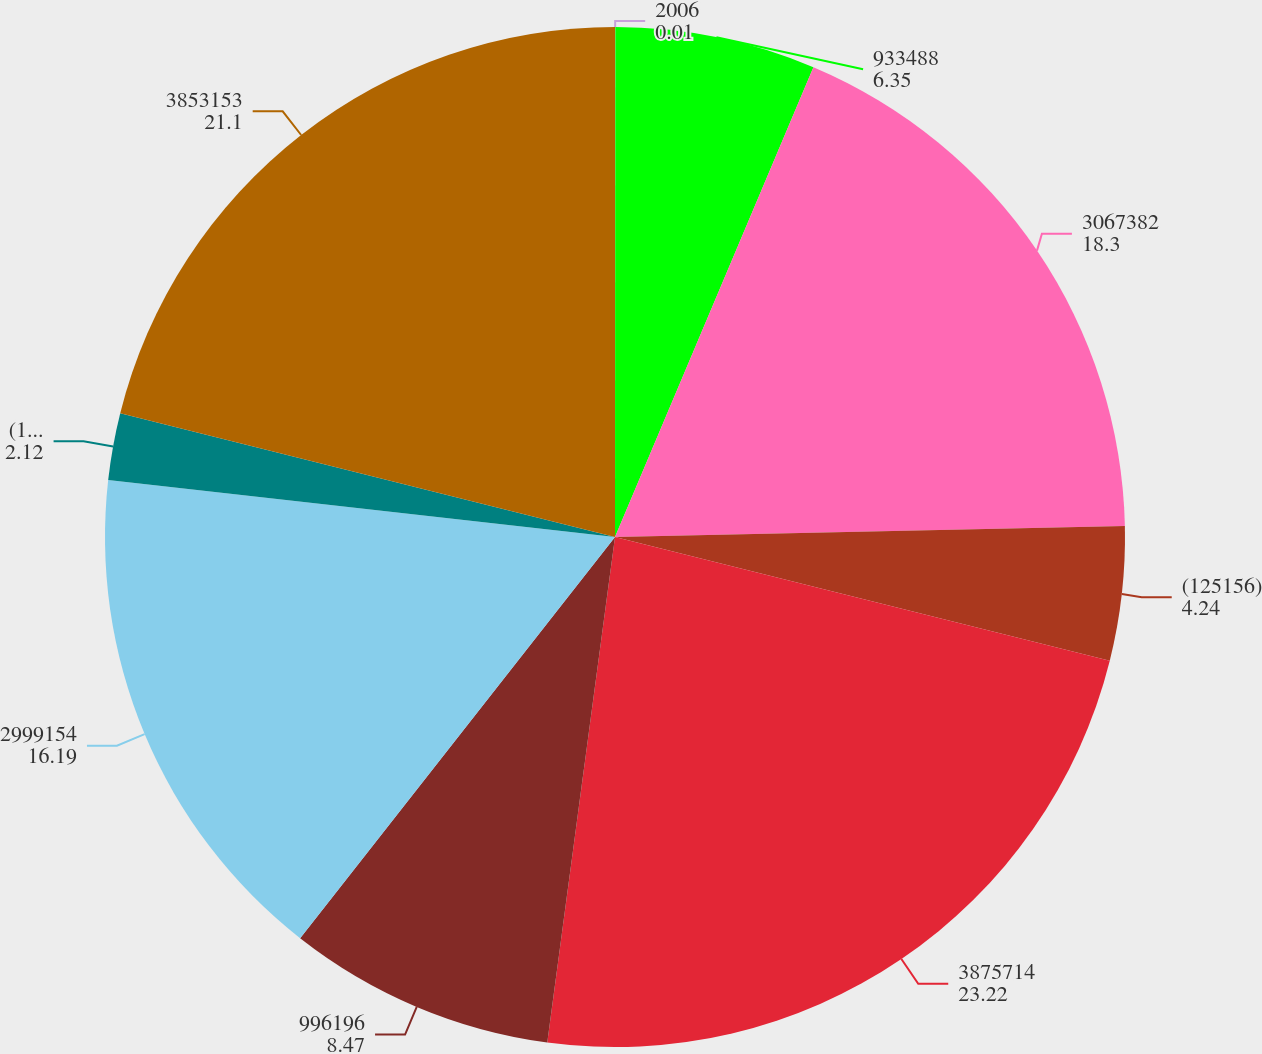Convert chart to OTSL. <chart><loc_0><loc_0><loc_500><loc_500><pie_chart><fcel>2006<fcel>933488<fcel>3067382<fcel>(125156)<fcel>3875714<fcel>996196<fcel>2999154<fcel>(142197)<fcel>3853153<nl><fcel>0.01%<fcel>6.35%<fcel>18.3%<fcel>4.24%<fcel>23.22%<fcel>8.47%<fcel>16.19%<fcel>2.12%<fcel>21.1%<nl></chart> 